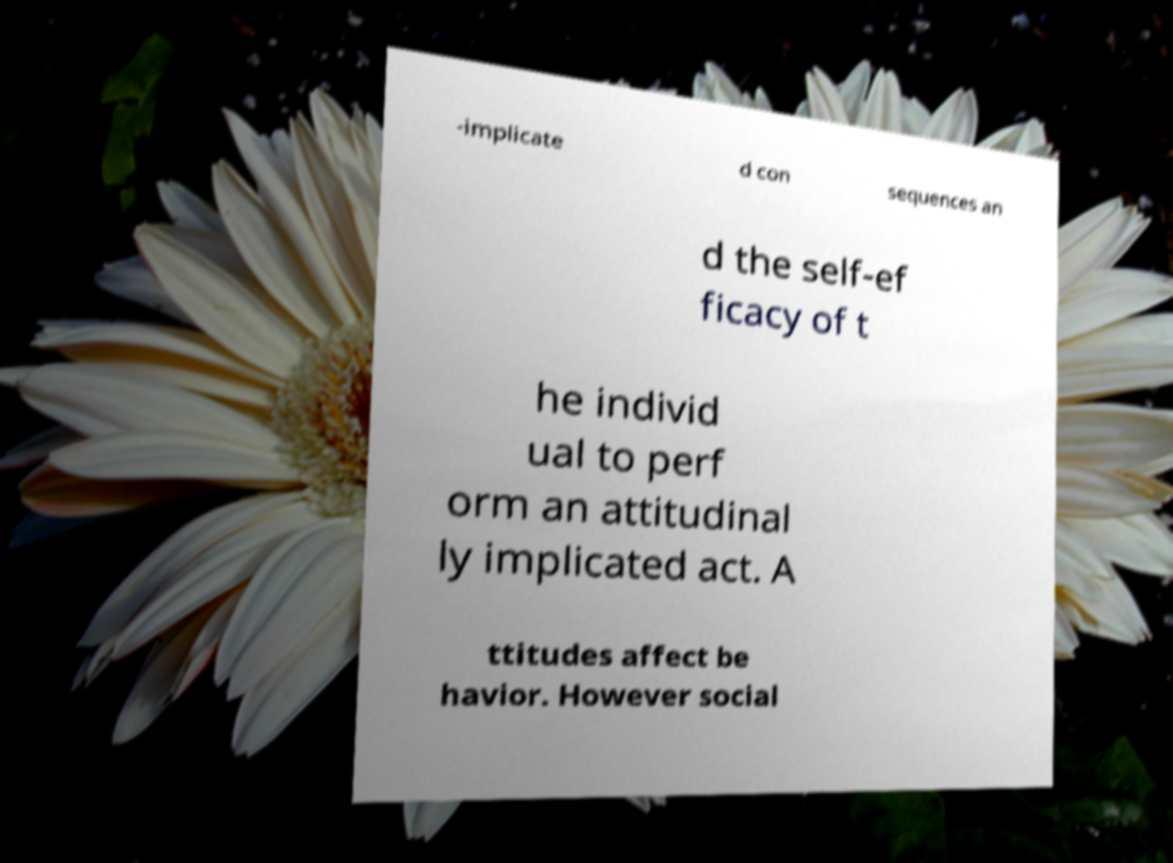For documentation purposes, I need the text within this image transcribed. Could you provide that? -implicate d con sequences an d the self-ef ficacy of t he individ ual to perf orm an attitudinal ly implicated act. A ttitudes affect be havior. However social 